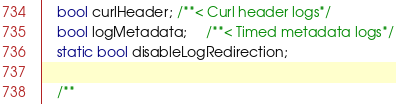<code> <loc_0><loc_0><loc_500><loc_500><_C_>	bool curlHeader; /**< Curl header logs*/
	bool logMetadata;	 /**< Timed metadata logs*/
	static bool disableLogRedirection;

	/**</code> 